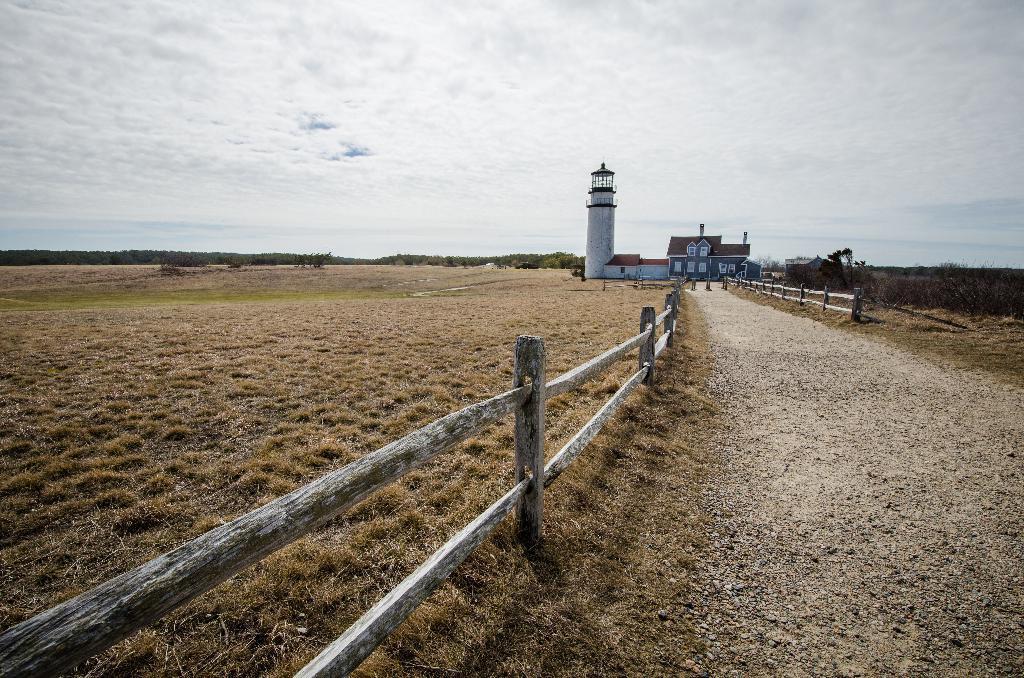In one or two sentences, can you explain what this image depicts? In this image we can see building, tower, wooden fence and other objects. In the background of the image there are trees. At the bottom of the image there are grass, wooden fence and ground. At the top of the image there is the sky. 